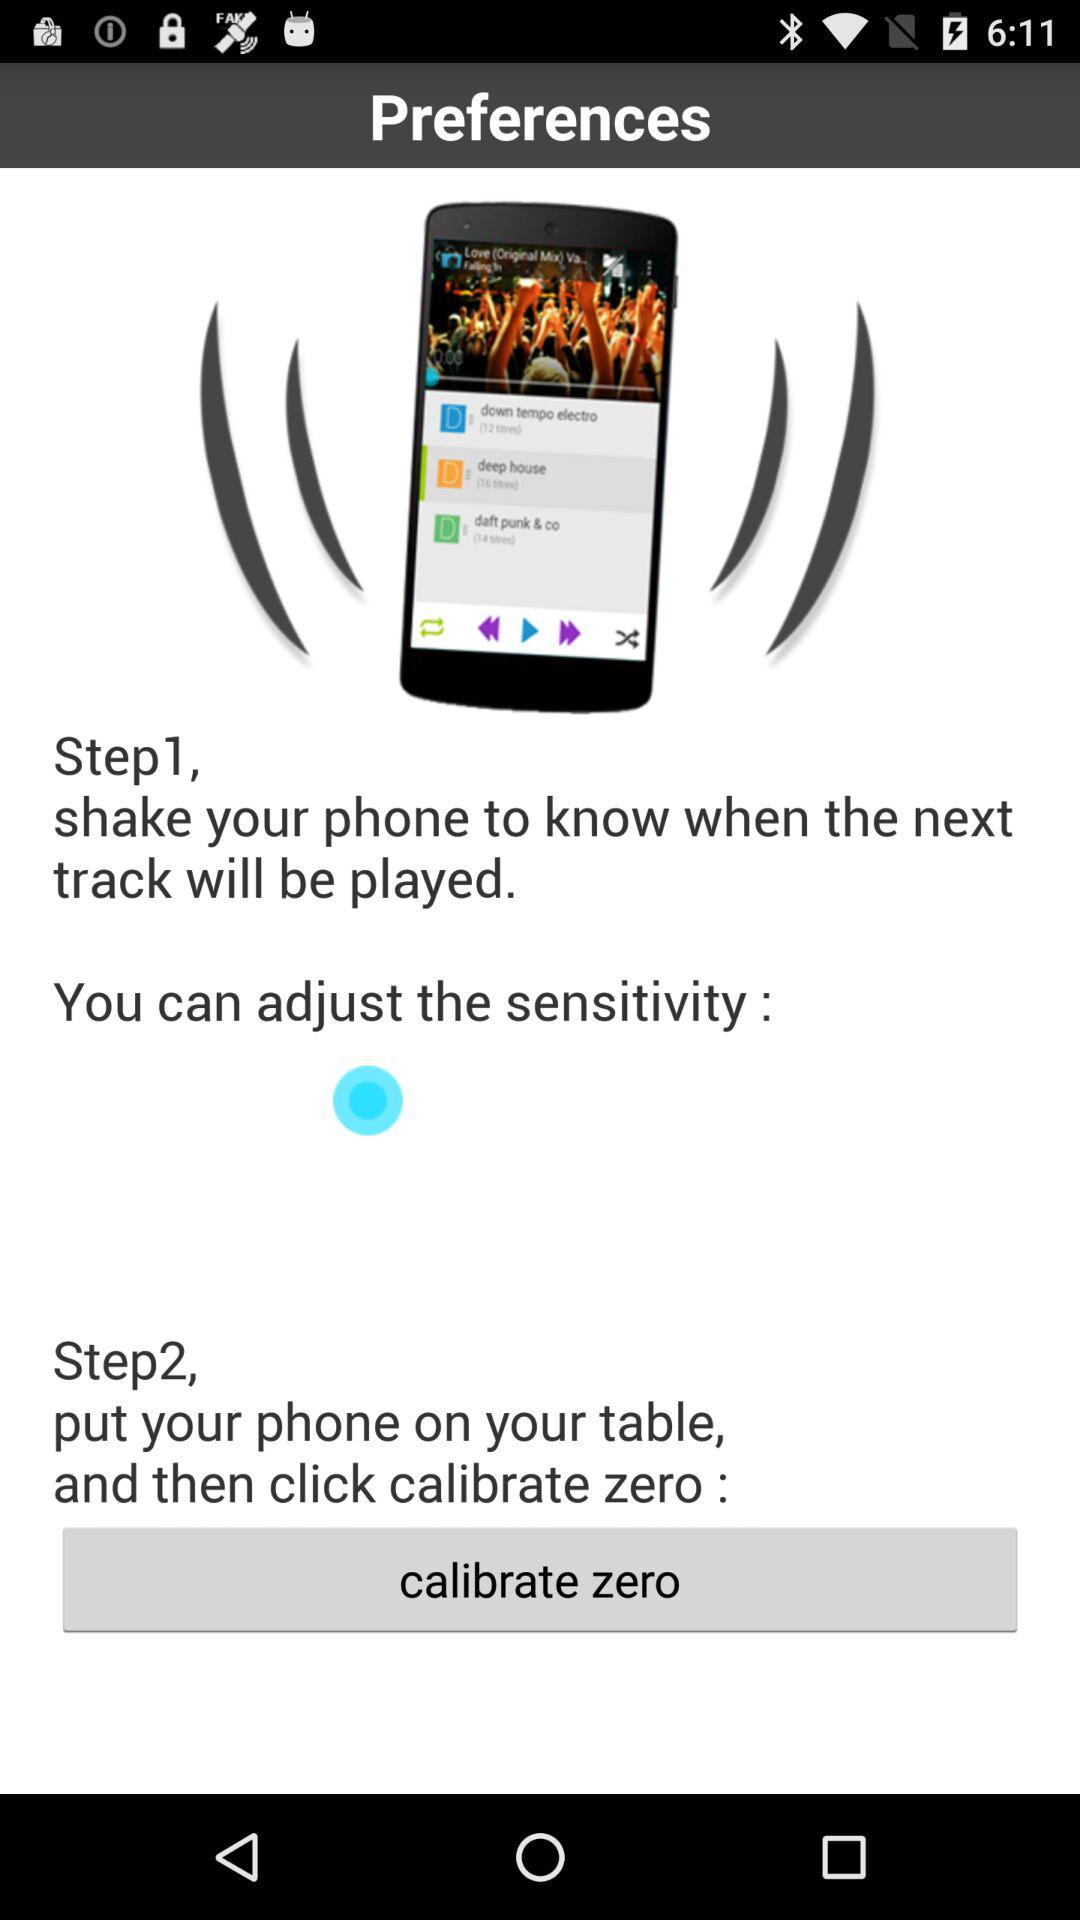How long does it take to calibrate?
When the provided information is insufficient, respond with <no answer>. <no answer> 